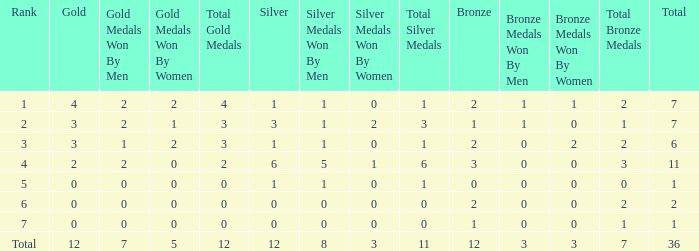What is the number of bronze medals when there are fewer than 0 silver medals? None. 